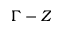<formula> <loc_0><loc_0><loc_500><loc_500>\Gamma - Z</formula> 